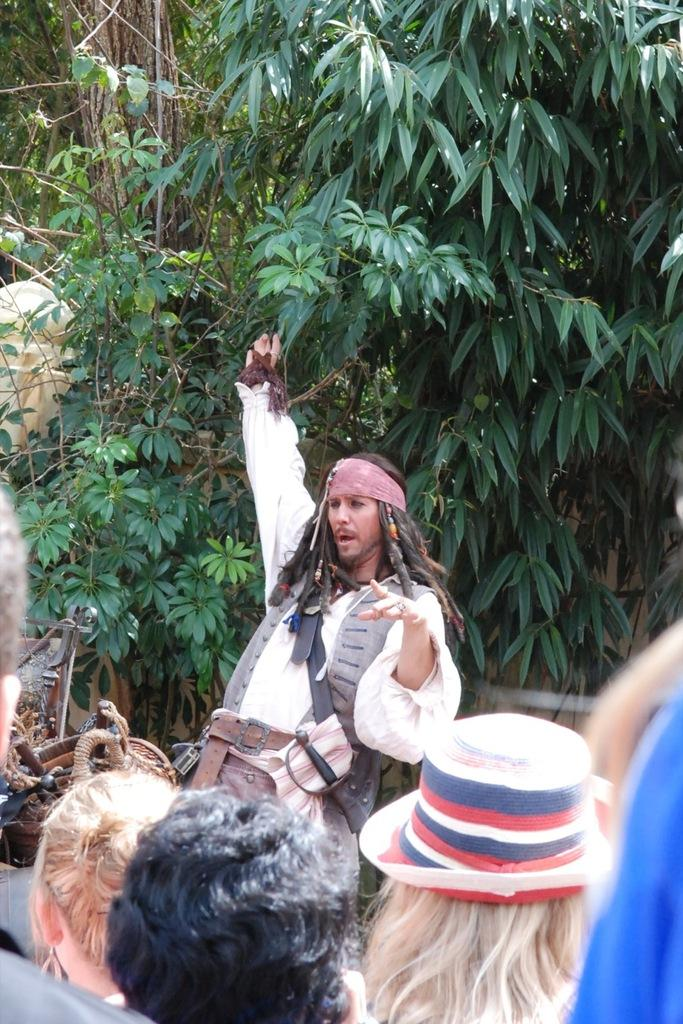Who or what can be seen in the image? There are people in the image. What type of natural environment is present in the image? There are trees in the image. What else can be observed in the image besides people and trees? There are objects in the image. Are there any boats visible in the image? There are no boats present in the image. What type of chair is being used by the people in the image? There is no chair visible in the image; the people are standing or sitting on the ground. 